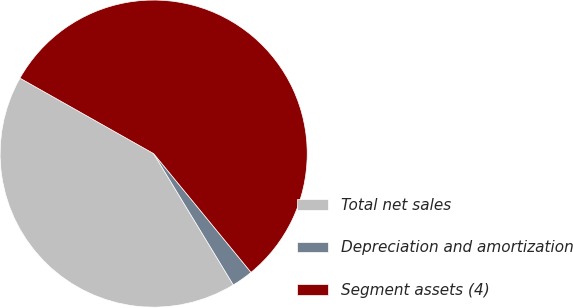Convert chart. <chart><loc_0><loc_0><loc_500><loc_500><pie_chart><fcel>Total net sales<fcel>Depreciation and amortization<fcel>Segment assets (4)<nl><fcel>41.86%<fcel>2.25%<fcel>55.89%<nl></chart> 